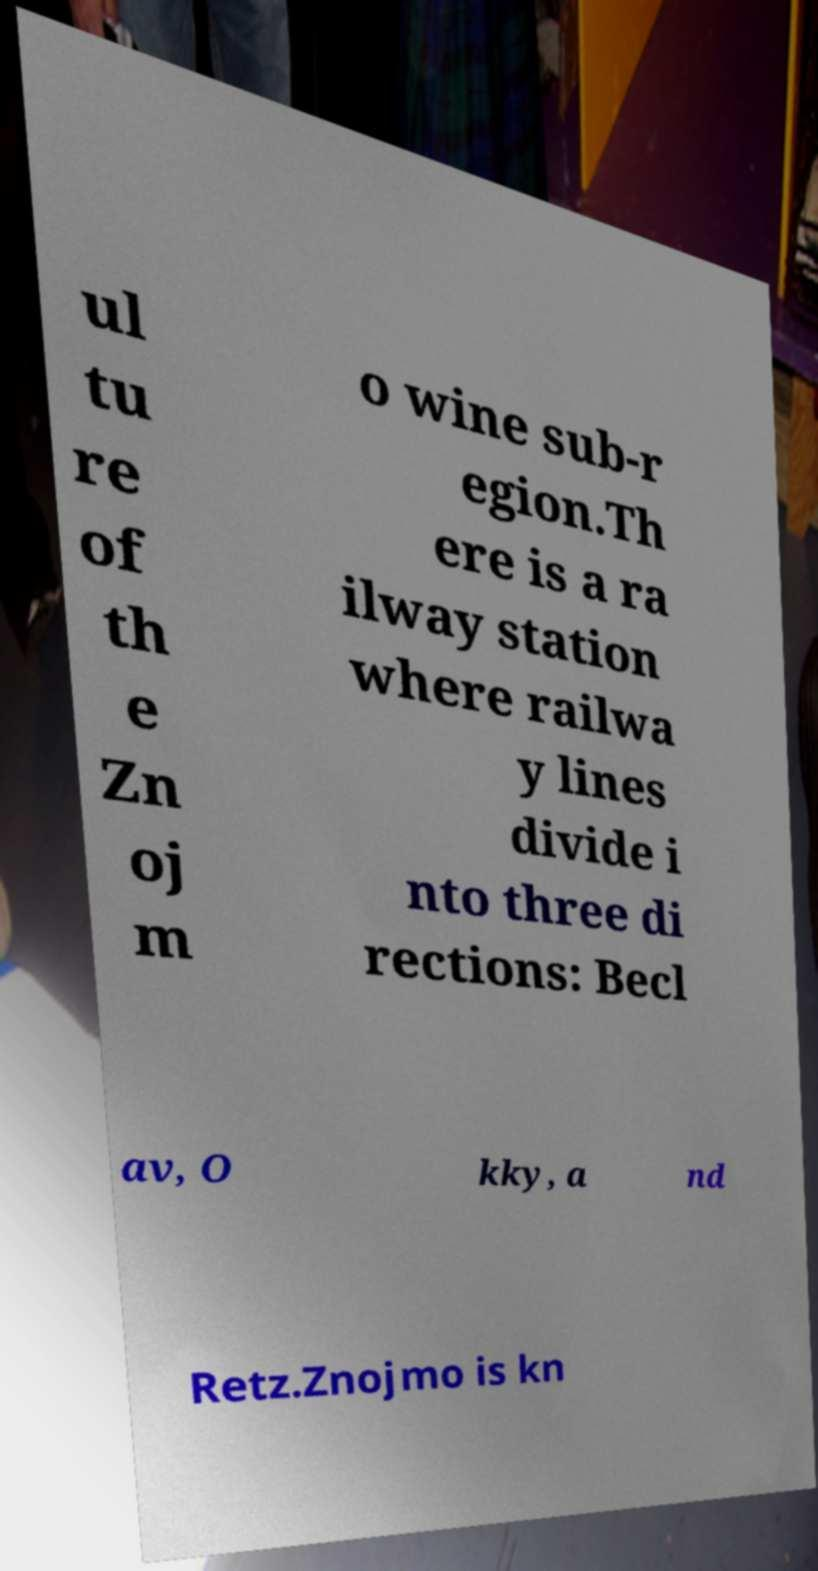Can you accurately transcribe the text from the provided image for me? ul tu re of th e Zn oj m o wine sub-r egion.Th ere is a ra ilway station where railwa y lines divide i nto three di rections: Becl av, O kky, a nd Retz.Znojmo is kn 